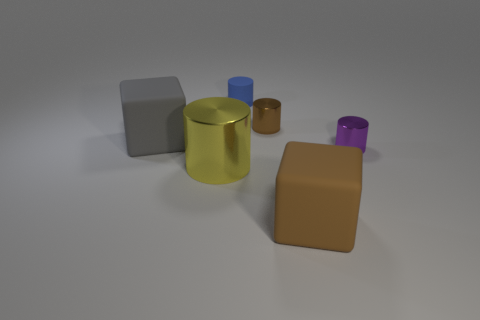Subtract all yellow metal cylinders. How many cylinders are left? 3 Add 1 cubes. How many objects exist? 7 Subtract all yellow cylinders. How many cylinders are left? 3 Subtract 1 cubes. How many cubes are left? 1 Subtract all brown cylinders. Subtract all green cubes. How many cylinders are left? 3 Subtract all gray blocks. How many yellow cylinders are left? 1 Subtract all large brown things. Subtract all gray cubes. How many objects are left? 4 Add 1 tiny blue objects. How many tiny blue objects are left? 2 Add 4 gray objects. How many gray objects exist? 5 Subtract 1 gray cubes. How many objects are left? 5 